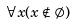Convert formula to latex. <formula><loc_0><loc_0><loc_500><loc_500>\forall x ( x \notin \emptyset )</formula> 